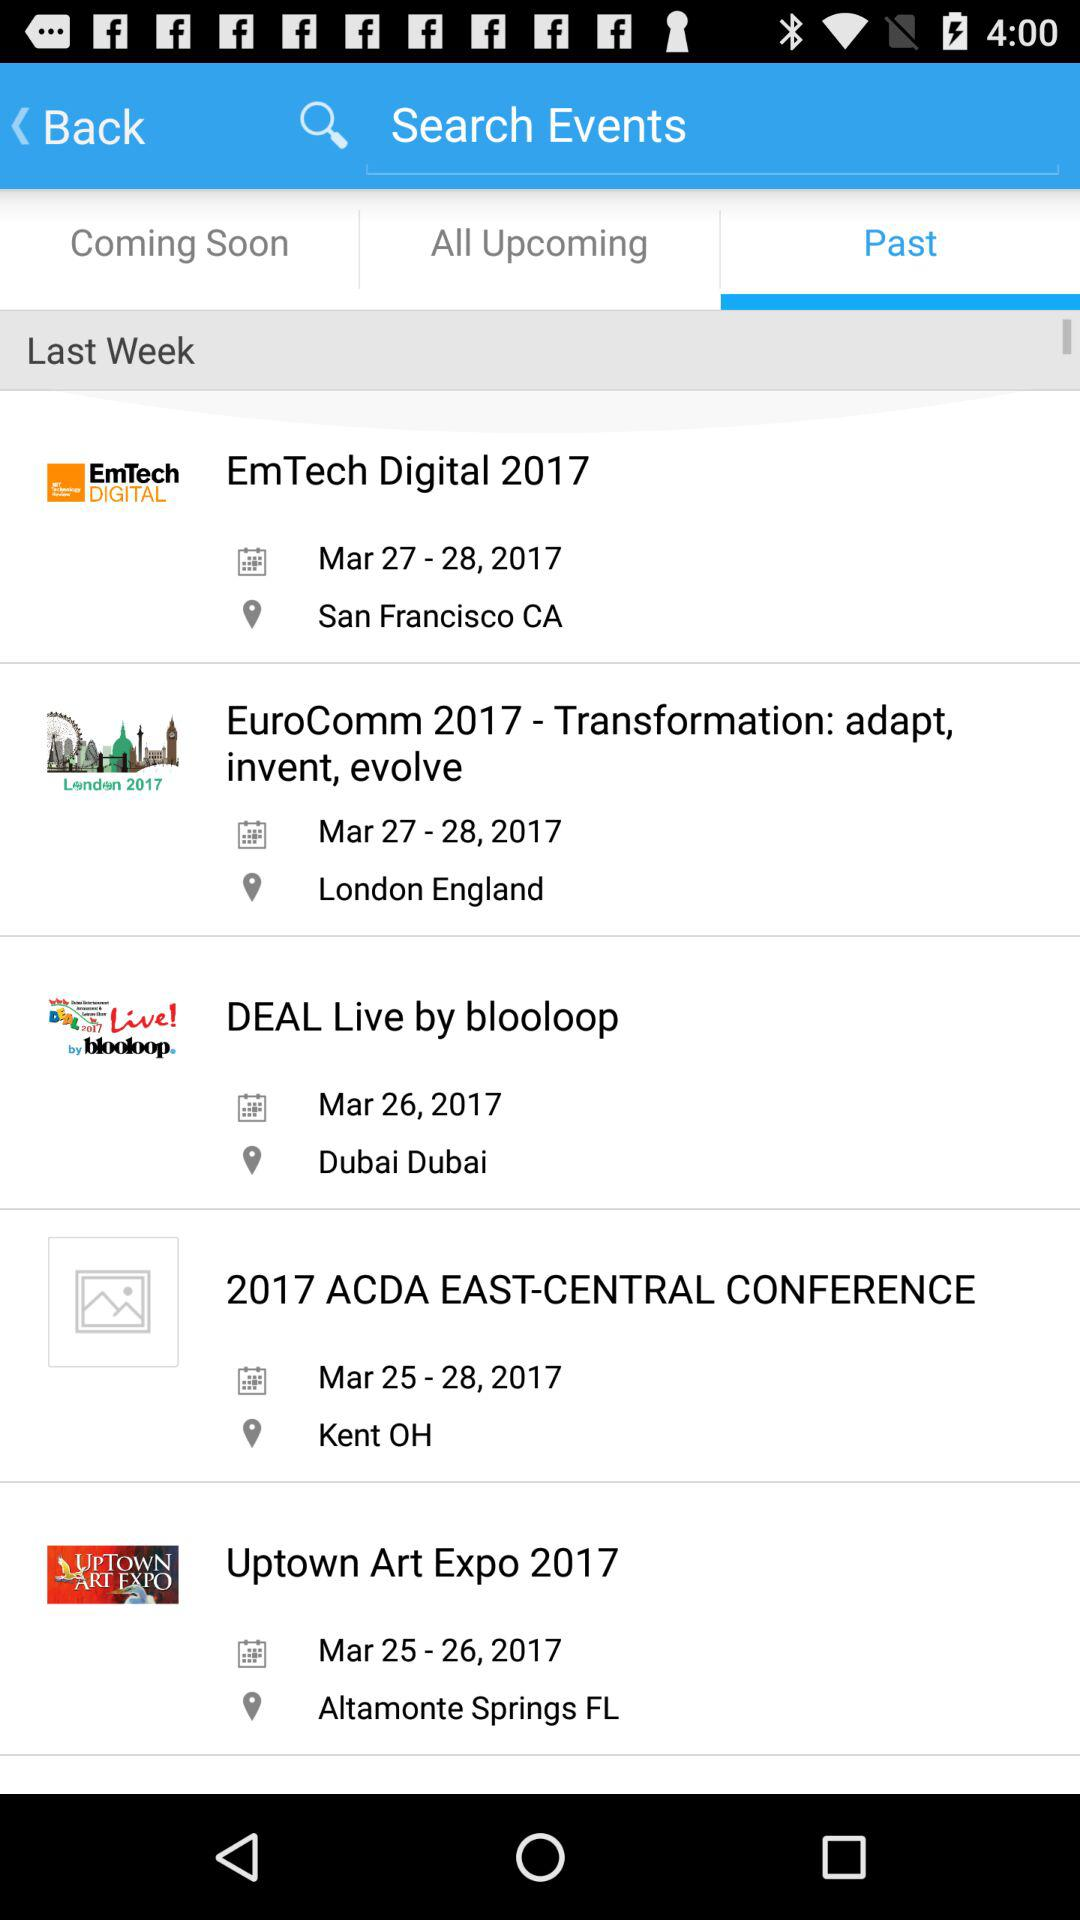Which option is selected? The selected option is "Past". 